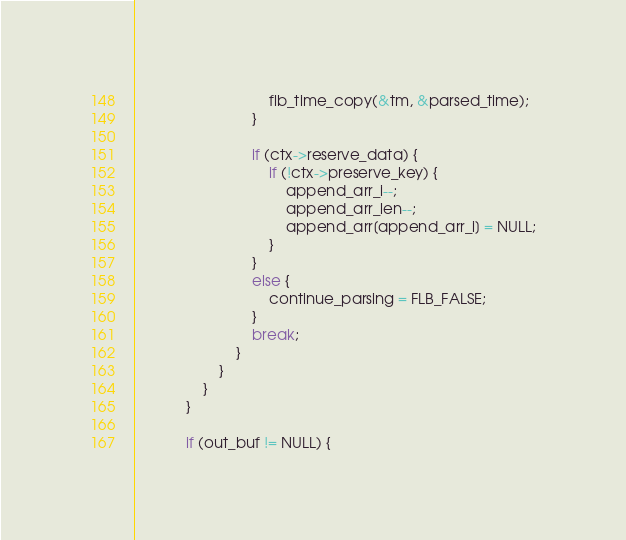Convert code to text. <code><loc_0><loc_0><loc_500><loc_500><_C_>                                flb_time_copy(&tm, &parsed_time);
                            }

                            if (ctx->reserve_data) {
                                if (!ctx->preserve_key) {
                                    append_arr_i--;
                                    append_arr_len--;
                                    append_arr[append_arr_i] = NULL;
                                }
                            }
                            else {
                                continue_parsing = FLB_FALSE;
                            }
                            break;
                        }
                    }
                }
            }

            if (out_buf != NULL) {</code> 